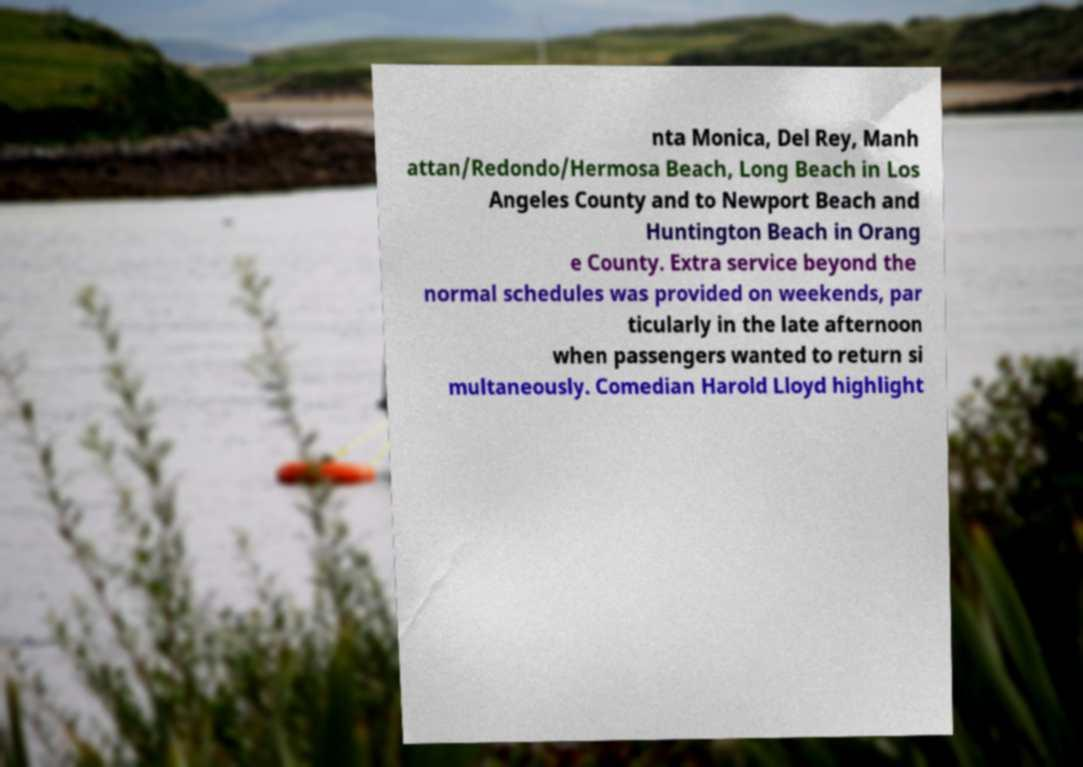I need the written content from this picture converted into text. Can you do that? nta Monica, Del Rey, Manh attan/Redondo/Hermosa Beach, Long Beach in Los Angeles County and to Newport Beach and Huntington Beach in Orang e County. Extra service beyond the normal schedules was provided on weekends, par ticularly in the late afternoon when passengers wanted to return si multaneously. Comedian Harold Lloyd highlight 